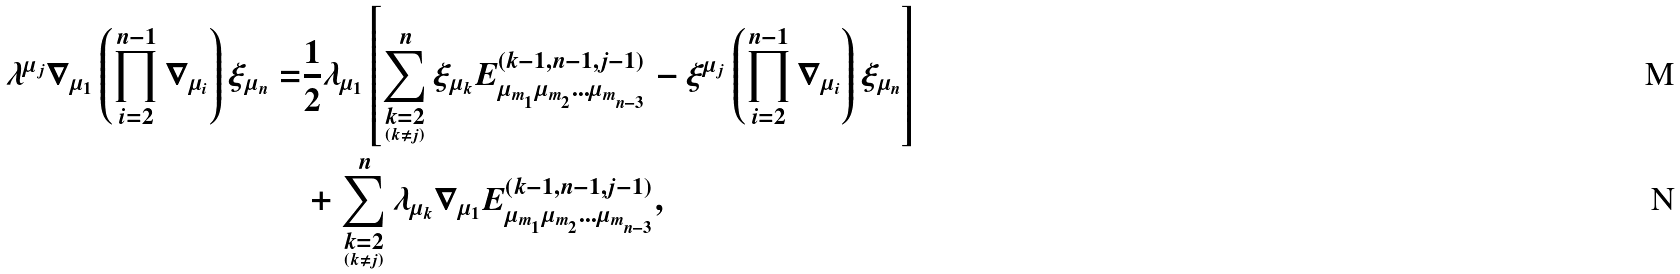<formula> <loc_0><loc_0><loc_500><loc_500>\lambda ^ { \mu _ { j } } \nabla _ { \mu _ { 1 } } \left ( \prod _ { i = 2 } ^ { n - 1 } \nabla _ { \mu _ { i } } \right ) \xi _ { \mu _ { n } } = & \frac { 1 } { 2 } \lambda _ { \mu _ { 1 } } \left [ \sum _ { \underset { \left ( k \ne j \right ) } { k = 2 } } ^ { n } \xi _ { \mu _ { k } } E _ { \mu _ { m _ { _ { 1 } } } \mu _ { m _ { _ { 2 } } } \dots \mu _ { m _ { _ { n - 3 } } } } ^ { \left ( k - 1 , n - 1 , j - 1 \right ) } - \xi ^ { \mu _ { j } } \left ( \prod _ { i = 2 } ^ { n - 1 } \nabla _ { \mu _ { i } } \right ) \xi _ { \mu _ { n } } \right ] \\ & + \sum _ { \underset { \left ( k \ne j \right ) } { k = 2 } } ^ { n } \lambda _ { \mu _ { k } } \nabla _ { \mu _ { 1 } } E _ { \mu _ { m _ { _ { 1 } } } \mu _ { m _ { _ { 2 } } } \dots \mu _ { m _ { _ { n - 3 } } } } ^ { \left ( k - 1 , n - 1 , j - 1 \right ) } ,</formula> 